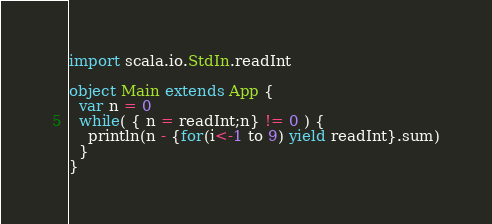<code> <loc_0><loc_0><loc_500><loc_500><_Scala_>import scala.io.StdIn.readInt

object Main extends App {
  var n = 0
  while( { n = readInt;n} != 0 ) {
    println(n - {for(i<-1 to 9) yield readInt}.sum)
  }
}</code> 